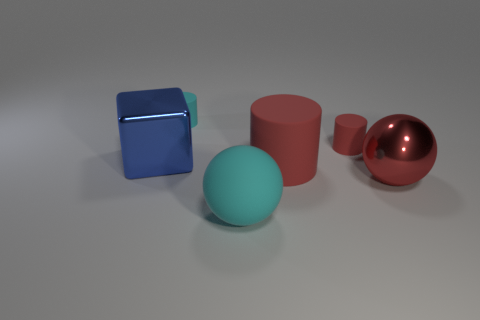Is the number of blocks right of the metallic ball the same as the number of big blue things?
Your answer should be compact. No. What number of objects are behind the big cyan thing and in front of the small cyan object?
Make the answer very short. 4. Does the cyan matte thing that is in front of the tiny cyan object have the same shape as the big red shiny thing?
Your response must be concise. Yes. What is the material of the red sphere that is the same size as the block?
Offer a terse response. Metal. Is the number of large matte cylinders that are in front of the big cyan thing the same as the number of red cylinders that are to the left of the small red object?
Your answer should be compact. No. There is a large rubber thing that is to the right of the large rubber object that is in front of the large red cylinder; what number of red cylinders are behind it?
Keep it short and to the point. 1. There is a large cylinder; is its color the same as the small cylinder that is on the right side of the large cyan ball?
Keep it short and to the point. Yes. What size is the cyan object that is made of the same material as the cyan cylinder?
Your answer should be very brief. Large. Are there more objects on the left side of the big red metallic object than big metal objects?
Provide a short and direct response. Yes. There is a ball that is right of the big ball in front of the shiny sphere on the right side of the cyan cylinder; what is it made of?
Provide a short and direct response. Metal. 